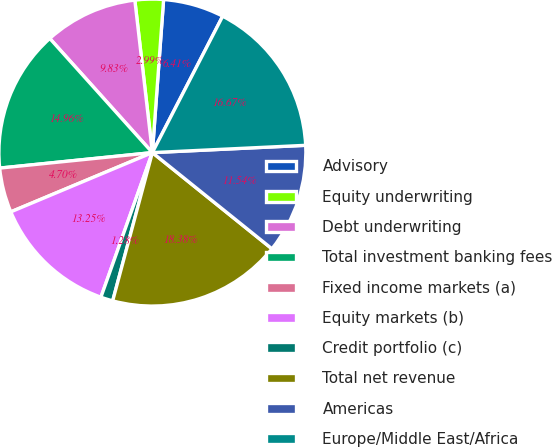Convert chart to OTSL. <chart><loc_0><loc_0><loc_500><loc_500><pie_chart><fcel>Advisory<fcel>Equity underwriting<fcel>Debt underwriting<fcel>Total investment banking fees<fcel>Fixed income markets (a)<fcel>Equity markets (b)<fcel>Credit portfolio (c)<fcel>Total net revenue<fcel>Americas<fcel>Europe/Middle East/Africa<nl><fcel>6.41%<fcel>2.99%<fcel>9.83%<fcel>14.96%<fcel>4.7%<fcel>13.25%<fcel>1.28%<fcel>18.38%<fcel>11.54%<fcel>16.67%<nl></chart> 